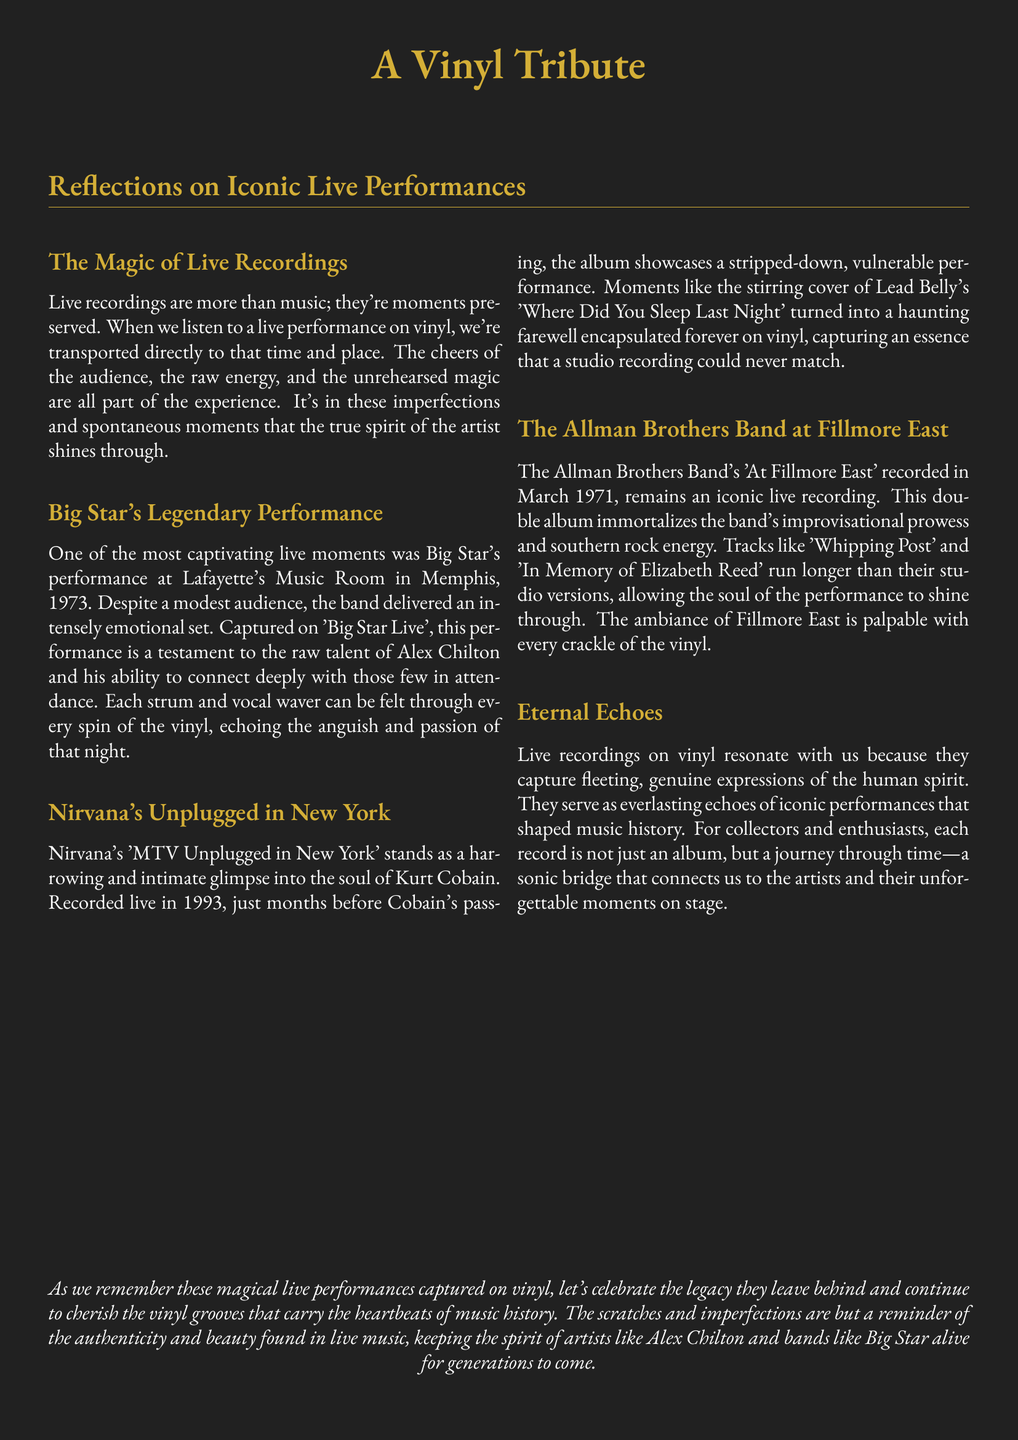What year did Big Star perform at Lafayette's Music Room? The document states that Big Star performed at Lafayette's Music Room in Memphis in 1973.
Answer: 1973 What is the name of the album capturing Nirvana's live performance? The document mentions the live performance captured in an album titled 'MTV Unplugged in New York'.
Answer: MTV Unplugged in New York Which band performed at Fillmore East in 1971? The document explicitly states that The Allman Brothers Band performed at Fillmore East in March 1971.
Answer: The Allman Brothers Band What song did Kurt Cobain cover during the MTV Unplugged performance? The document highlights that Kurt Cobain performed a cover of Lead Belly's 'Where Did You Sleep Last Night'.
Answer: Where Did You Sleep Last Night How do live recordings on vinyl resonate with listeners according to the document? The document explains that live recordings resonate with listeners because they capture genuine expressions of the human spirit.
Answer: Genuine expressions of the human spirit What is described as 'a sonic bridge' in the document? According to the document, the records serve as a 'sonic bridge' that connects listeners to the artists and their unforgettable moments on stage.
Answer: Sonic bridge What is emphasized about the imperfections in live music recordings? The document states that scratches and imperfections remind us of the authenticity and beauty found in live music.
Answer: Authenticity and beauty What notable performance is mentioned as taking place in 1993? The document references Nirvana's 'MTV Unplugged in New York', which was recorded in 1993.
Answer: MTV Unplugged in New York What emotional aspect is highlighted in Big Star's performance? The document indicates that Big Star delivered an intensely emotional set during their performance.
Answer: Intensely emotional set 